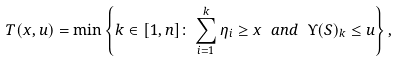<formula> <loc_0><loc_0><loc_500><loc_500>T ( x , u ) = \min \left \{ k \in [ 1 , n ] \colon \sum _ { i = 1 } ^ { k } \eta _ { i } \geq x \ a n d \ \Upsilon ( S ) _ { k } \leq u \right \} ,</formula> 